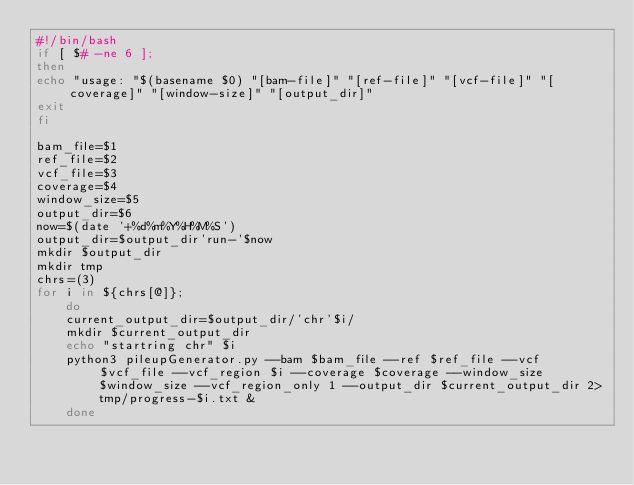<code> <loc_0><loc_0><loc_500><loc_500><_Bash_>#!/bin/bash
if [ $# -ne 6 ];
then
echo "usage: "$(basename $0) "[bam-file]" "[ref-file]" "[vcf-file]" "[coverage]" "[window-size]" "[output_dir]"
exit
fi

bam_file=$1
ref_file=$2
vcf_file=$3
coverage=$4
window_size=$5
output_dir=$6
now=$(date '+%d%m%Y%H%M%S')
output_dir=$output_dir'run-'$now
mkdir $output_dir
mkdir tmp
chrs=(3)
for i in ${chrs[@]};
    do
    current_output_dir=$output_dir/'chr'$i/
    mkdir $current_output_dir
    echo "startring chr" $i
    python3 pileupGenerator.py --bam $bam_file --ref $ref_file --vcf $vcf_file --vcf_region $i --coverage $coverage --window_size $window_size --vcf_region_only 1 --output_dir $current_output_dir 2>tmp/progress-$i.txt &
    done
</code> 